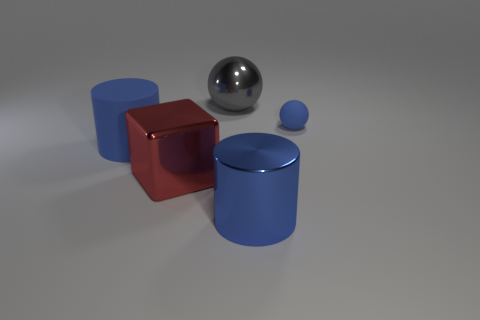Add 3 blue spheres. How many objects exist? 8 Subtract all cubes. How many objects are left? 4 Add 2 tiny blue matte balls. How many tiny blue matte balls exist? 3 Subtract 0 yellow blocks. How many objects are left? 5 Subtract all blue objects. Subtract all tiny gray matte blocks. How many objects are left? 2 Add 3 big red shiny blocks. How many big red shiny blocks are left? 4 